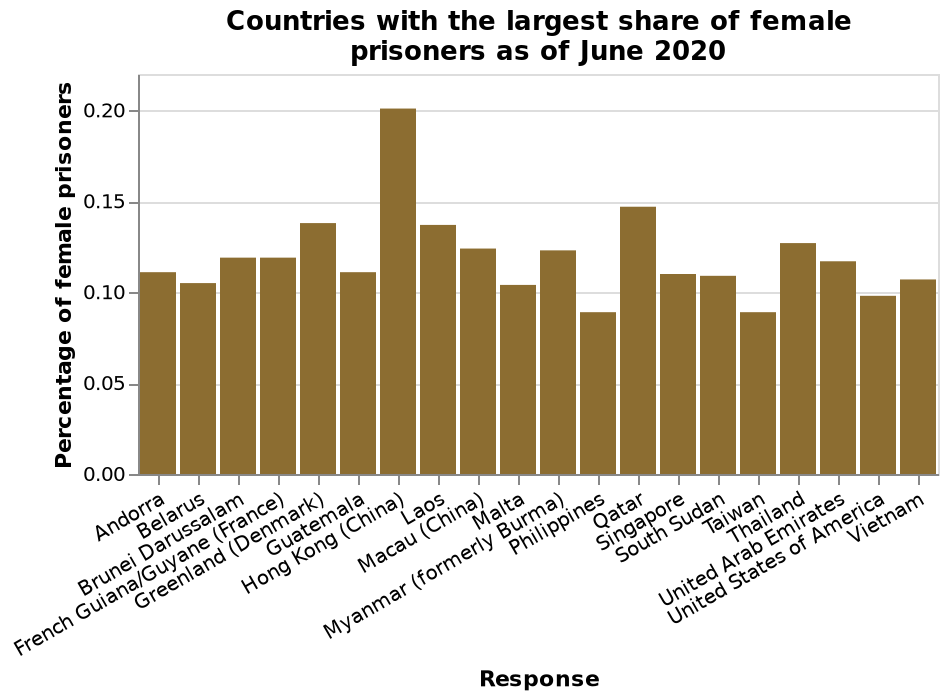<image>
What are the countries with the smallest share of female prisoners? Taiwan and Philippines have the smallest share of female prisoners. What is the range of the y-axis on the bar chart?  The y-axis on the bar chart shows the percentage of female prisoners on a linear scale, ranging from a minimum of 0.00 to a maximum of 0.20. please summary the statistics and relations of the chart Hong Kong has the highest proportion of Female prisoners compare to the other countries. Qatar is the 2nd noticeable country with the highest proportion of Female prisoners. Brunei Darussalam and French Guiana / Guyane show the same percentage of Female prisoners as of June 2020. What country has the largest share of female prisoners according to the graph?  Hong Kong (China) has the largest share of female prisoners. Describe the following image in detail Countries with the largest share of female prisoners as of June 2020 is a bar chart. On the x-axis, Response is measured with a categorical scale from Andorra to Vietnam. The y-axis shows Percentage of female prisoners on a linear scale with a minimum of 0.00 and a maximum of 0.20. Which country has the lowest percentage of female prisoners?  The bar chart does not provide information on the country with the lowest percentage of female prisoners. 